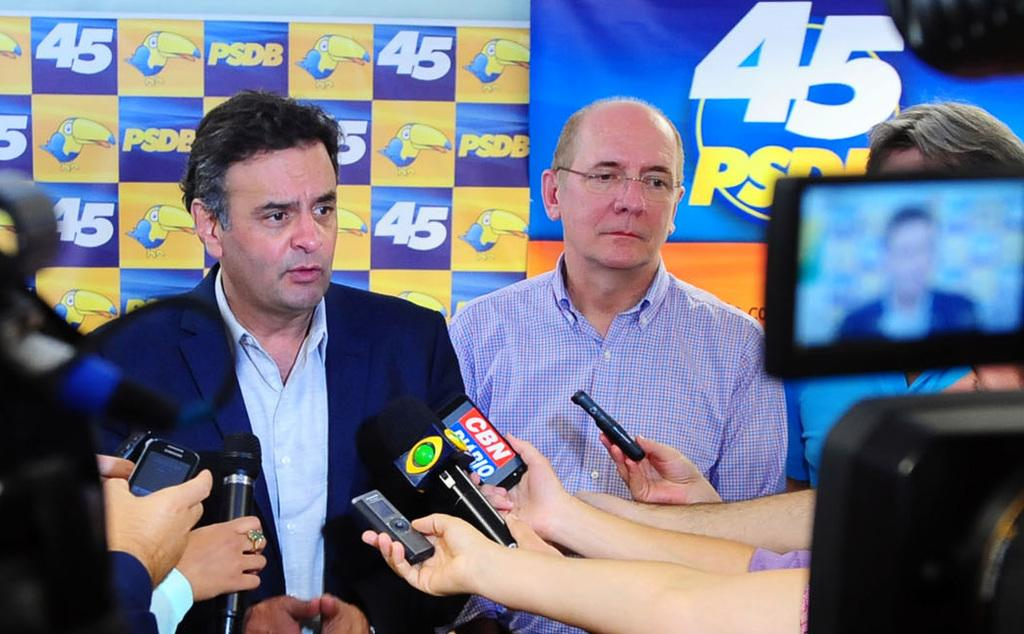What can be observed about the people in the image? There are people in the image, and some of them are holding microphones. What else are the people holding besides microphones? Some people are holding other objects in the image. What can be seen in the background of the image? There are banners in the background of the image. Can you tell me how many horses are present in the image? There are no horses present in the image. Is there a swimming pool visible in the image? There is no swimming pool visible in the image. 